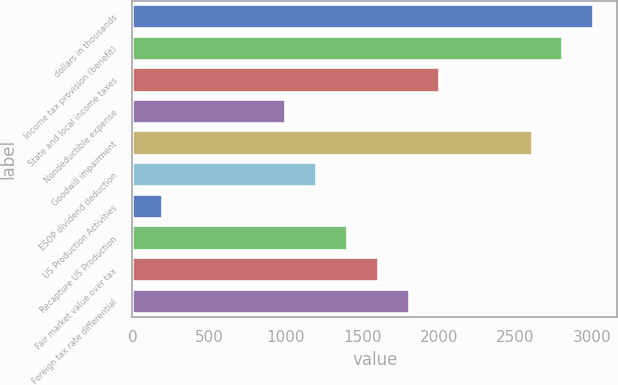<chart> <loc_0><loc_0><loc_500><loc_500><bar_chart><fcel>dollars in thousands<fcel>Income tax provision (benefit)<fcel>State and local income taxes<fcel>Nondeductible expense<fcel>Goodwill impairment<fcel>ESOP dividend deduction<fcel>US Production Activities<fcel>Recapture US Production<fcel>Fair market value over tax<fcel>Foreign tax rate differential<nl><fcel>3014.9<fcel>2813.92<fcel>2010<fcel>1005.1<fcel>2612.94<fcel>1206.08<fcel>201.18<fcel>1407.06<fcel>1608.04<fcel>1809.02<nl></chart> 